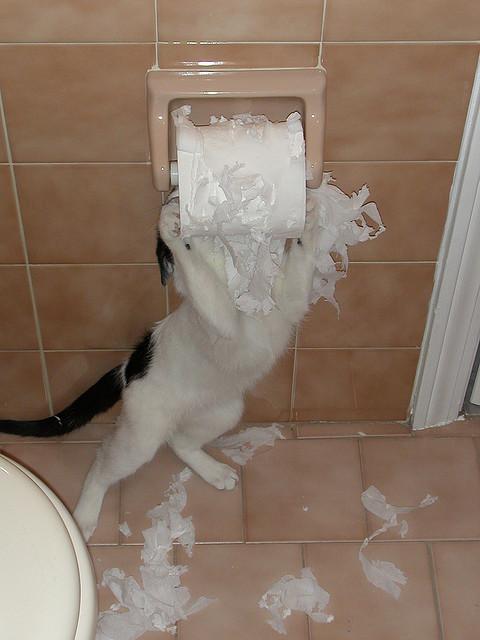What is on the wall?
Give a very brief answer. Tile. Why is the cat clawing the toilet paper?
Write a very short answer. Playing. Is this humorous?
Keep it brief. Yes. 